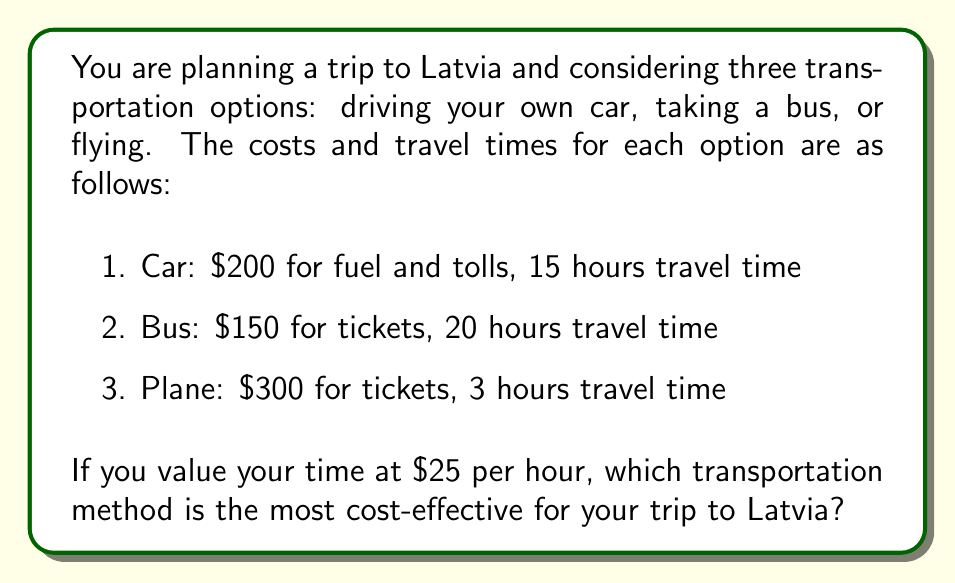Teach me how to tackle this problem. To determine the most cost-effective transportation method, we need to calculate the total cost for each option, including both the monetary cost and the value of time spent traveling.

Let's calculate the total cost for each option:

1. Car:
   Monetary cost = $200
   Time cost = 15 hours × $25/hour = $375
   Total cost = $200 + $375 = $575

2. Bus:
   Monetary cost = $150
   Time cost = 20 hours × $25/hour = $500
   Total cost = $150 + $500 = $650

3. Plane:
   Monetary cost = $300
   Time cost = 3 hours × $25/hour = $75
   Total cost = $300 + $75 = $375

To compare the cost-effectiveness, we can use the formula:

$$ \text{Cost-effectiveness} = \frac{\text{Total cost}}{\text{Distance traveled}} $$

Since the distance traveled is the same for all options (the trip to Latvia), we can simply compare the total costs.

The plane has the lowest total cost at $375, followed by the car at $575, and the bus at $650.

Therefore, the most cost-effective transportation method for your trip to Latvia is flying.
Answer: Flying ($375 total cost) 